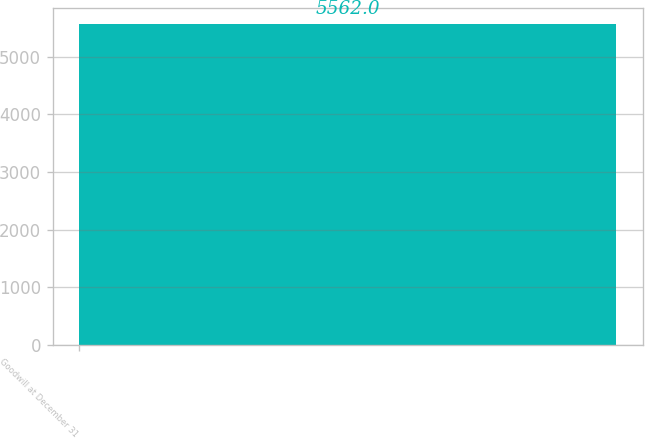<chart> <loc_0><loc_0><loc_500><loc_500><bar_chart><fcel>Goodwill at December 31<nl><fcel>5562<nl></chart> 